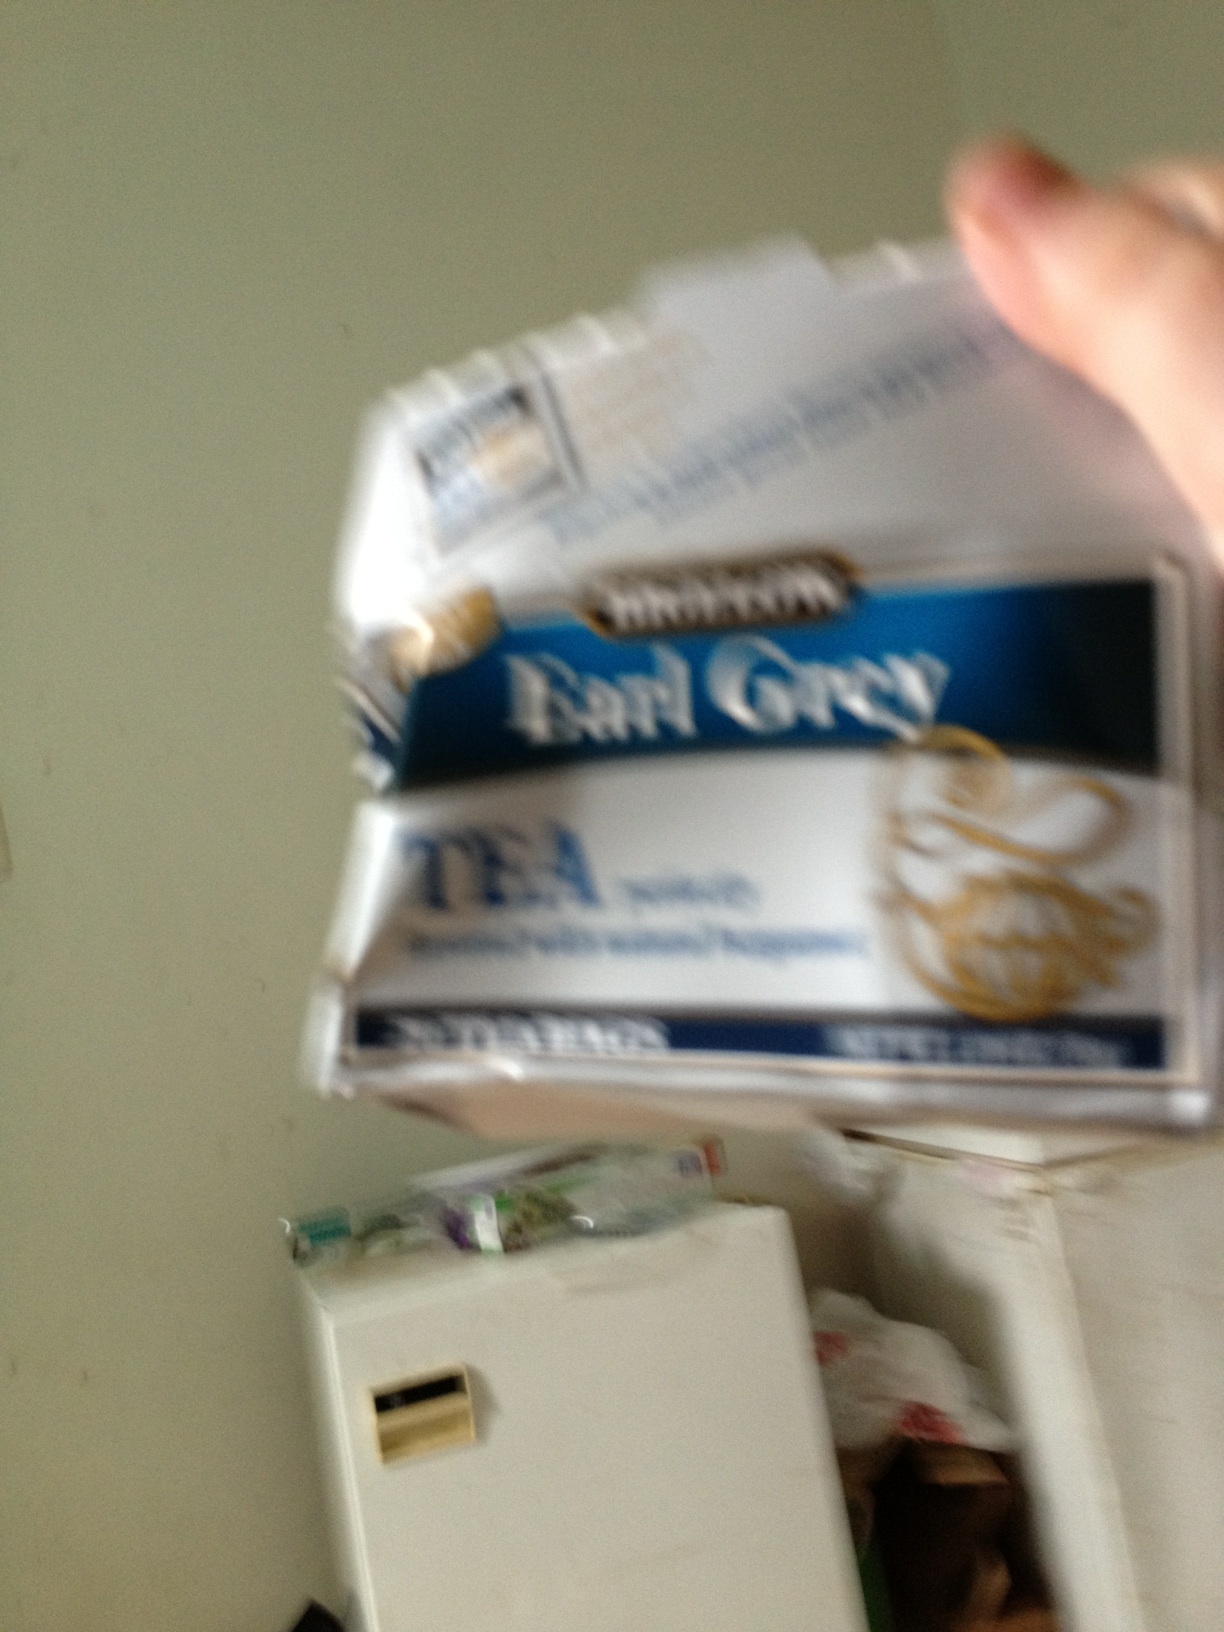Can you tell me how to brew the perfect cup of Earl Grey tea? Certainly! To brew a perfect cup of Earl Grey, start with fresh, cold water and bring it to a rolling boil. Then, pour the water over your Earl Grey tea bag or loose leaves in a cup or teapot, using about one teaspoon of tea leaves per cup. Steep the tea for 3-5 minutes depending on your taste preference for strength. Once steeped, remove the tea bag or leaves, and consider adding a slice of lemon or a dash of milk to enhance the flavor profile of the Earl Grey. Enjoy your aromatic and invigorating cup of tea! 